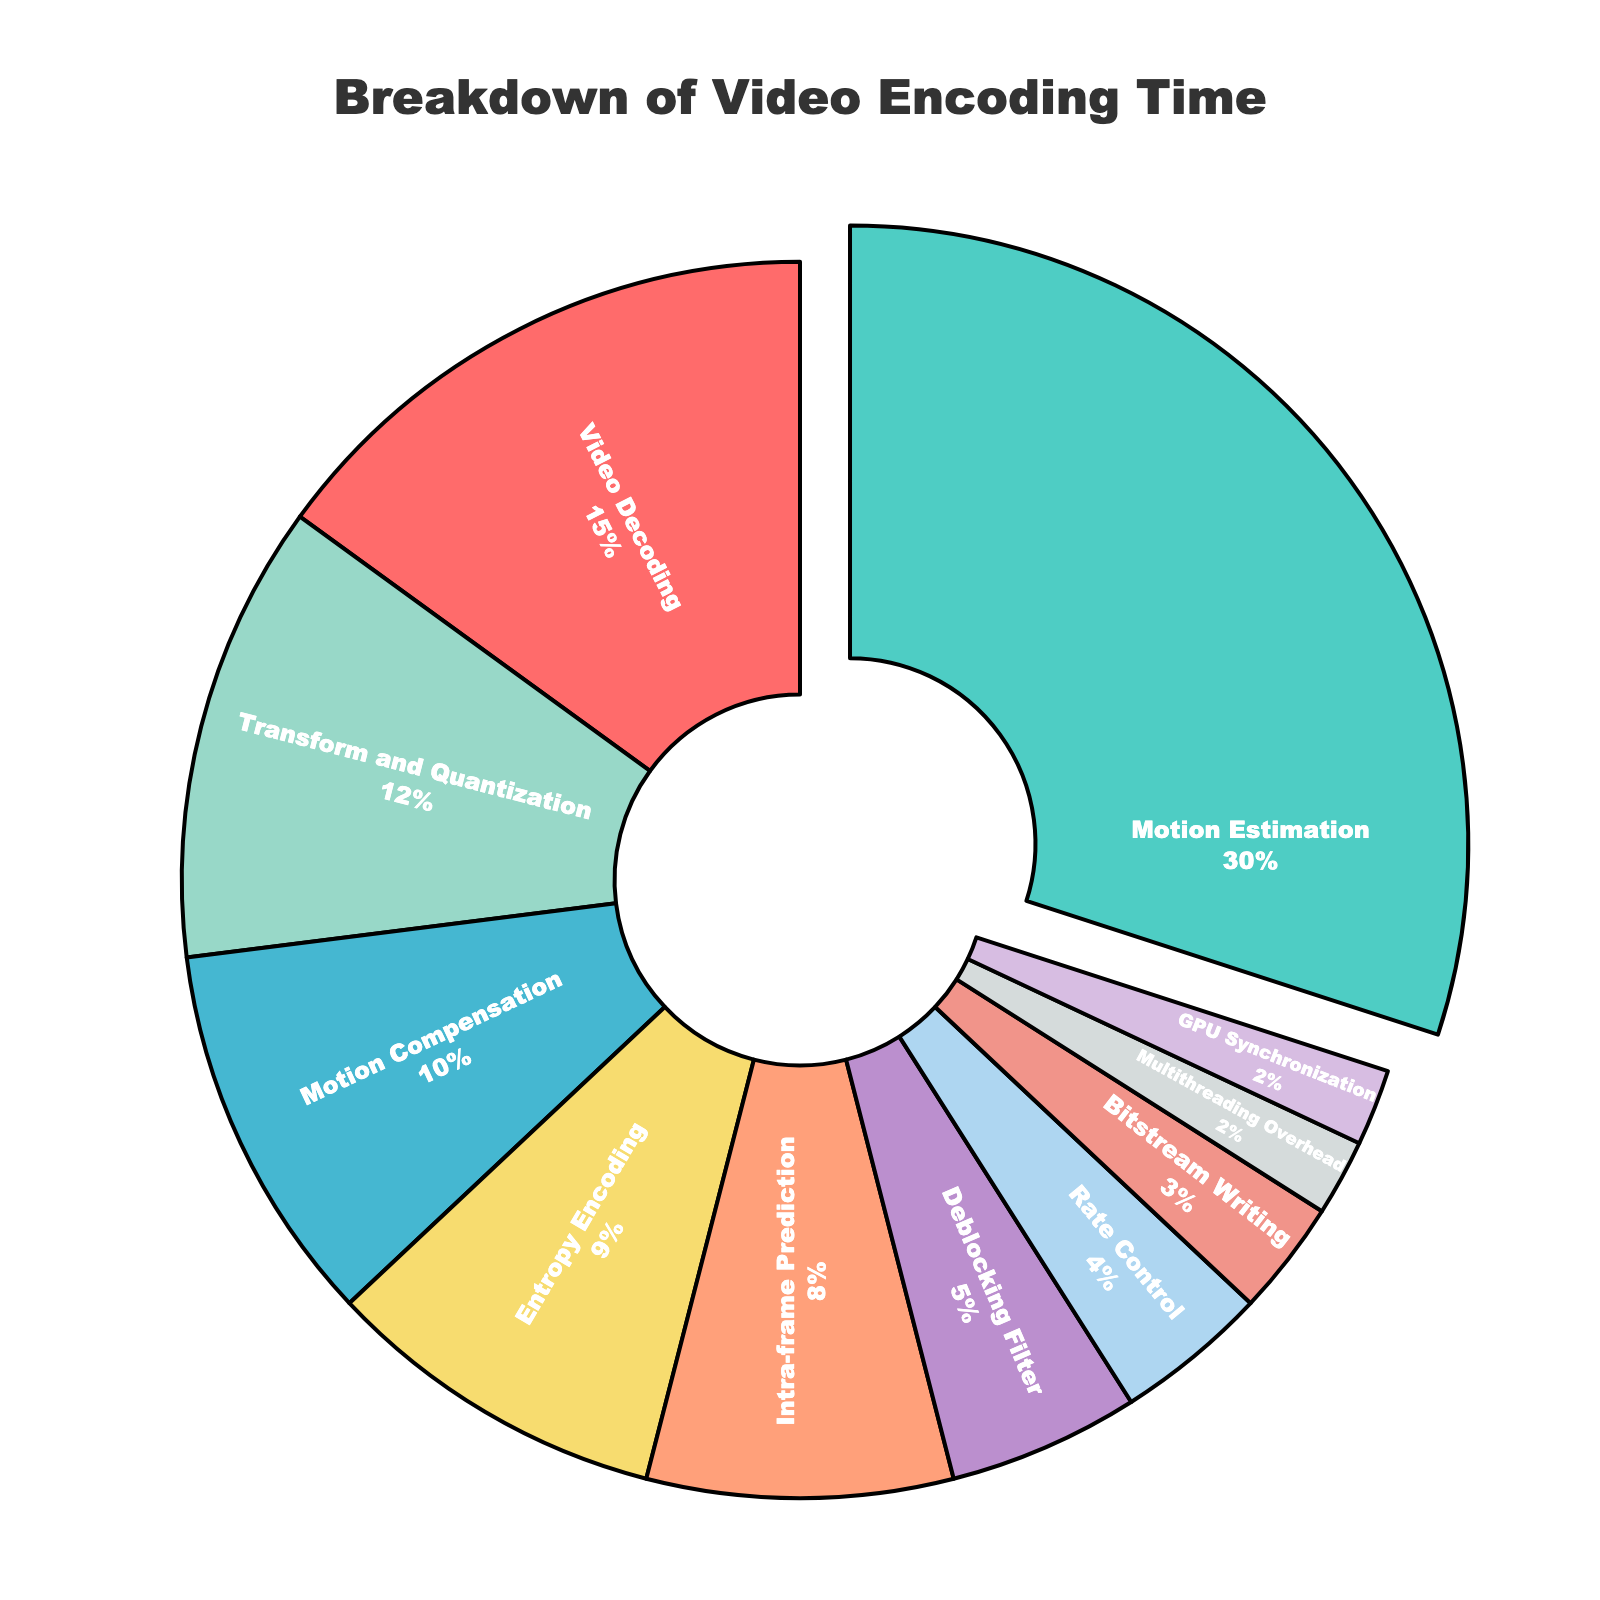What is the largest percentage stage in video encoding? The stage with the largest percentage is highlighted by being slightly pulled out from the pie chart. This stage is "Motion Estimation" with 30%.
Answer: Motion Estimation How much more time is spent on Motion Estimation compared to Rate Control? To find the difference, subtract the percentage of Rate Control from the percentage of Motion Estimation. Specifically: 30% - 4% = 26%.
Answer: 26% What two stages collectively contribute to 40% of the video encoding time? Look for two stages whose sums add up to 40%. In this case, "Motion Estimation" (30%) and "Video Decoding" (15%) collectively contribute 45%, which is not the correct combination. The right stages are "Motion Estimation" (30%) and "Transform and Quantization" (12%) which add up to 42%, not correct either. The correct sum involves "Video Decoding" (15%) and "Motion Estimation" (30%), but since the numbers need to add up to exactly 40%, such a pair doesn't exist in this dataset. However, a common close total would be considered if approximation is allowed.
Answer: N/A, no such exact pair Which stage occupies the smallest percentage of the video encoding process? The smallest segment in the pie chart represents GPU Synchronization and Multithreading Overhead, both with 2%.
Answer: GPU Synchronization and Multithreading Overhead How does the percentage of Intra-frame Prediction compare to that of Entropy Encoding? Compare the percentages directly. "Intra-frame Prediction" has 8% and "Entropy Encoding" has 9%.
Answer: Entropy Encoding is 1% higher than Intra-frame Prediction What is the sum of the percentages for Deblocking Filter and Rate Control stages? Add the percentages for "Deblocking Filter" and "Rate Control". Specifically: 5% + 4% = 9%.
Answer: 9% Which stage between Transform and Quantization and Bitstream Writing contributes more to the encoding time, and by how much? Compare the percentages directly. "Transform and Quantization" has 12%, and "Bitstream Writing" has 3%. The difference is calculated as 12% - 3% = 9%.
Answer: Transform and Quantization by 9% How many stages contribute less than 10% each to the encoding process? Count all the stages individually having percentages less than 10%. These stages are "Intra-frame Prediction" (8%), "Entropy Encoding" (9%), "Deblocking Filter" (5%), "Rate Control" (4%), "Bitstream Writing" (3%), "Multithreading Overhead" (2%), and "GPU Synchronization" (2%). There are 7 such stages.
Answer: 7 What is the combined percentage of all stages excluding Motion Estimation? Subtract the percentage of "Motion Estimation" from 100%. Specifically: 100% - 30% = 70%.
Answer: 70% Given that Motion Compensation, Transform and Quantization, and Deblocking Filter together make up 27%, what percentage of encoding time is spent on all other stages? Subtract the combined percentage of the three stages from 100%. Specifically: 100% - 27% = 73%.
Answer: 73% 